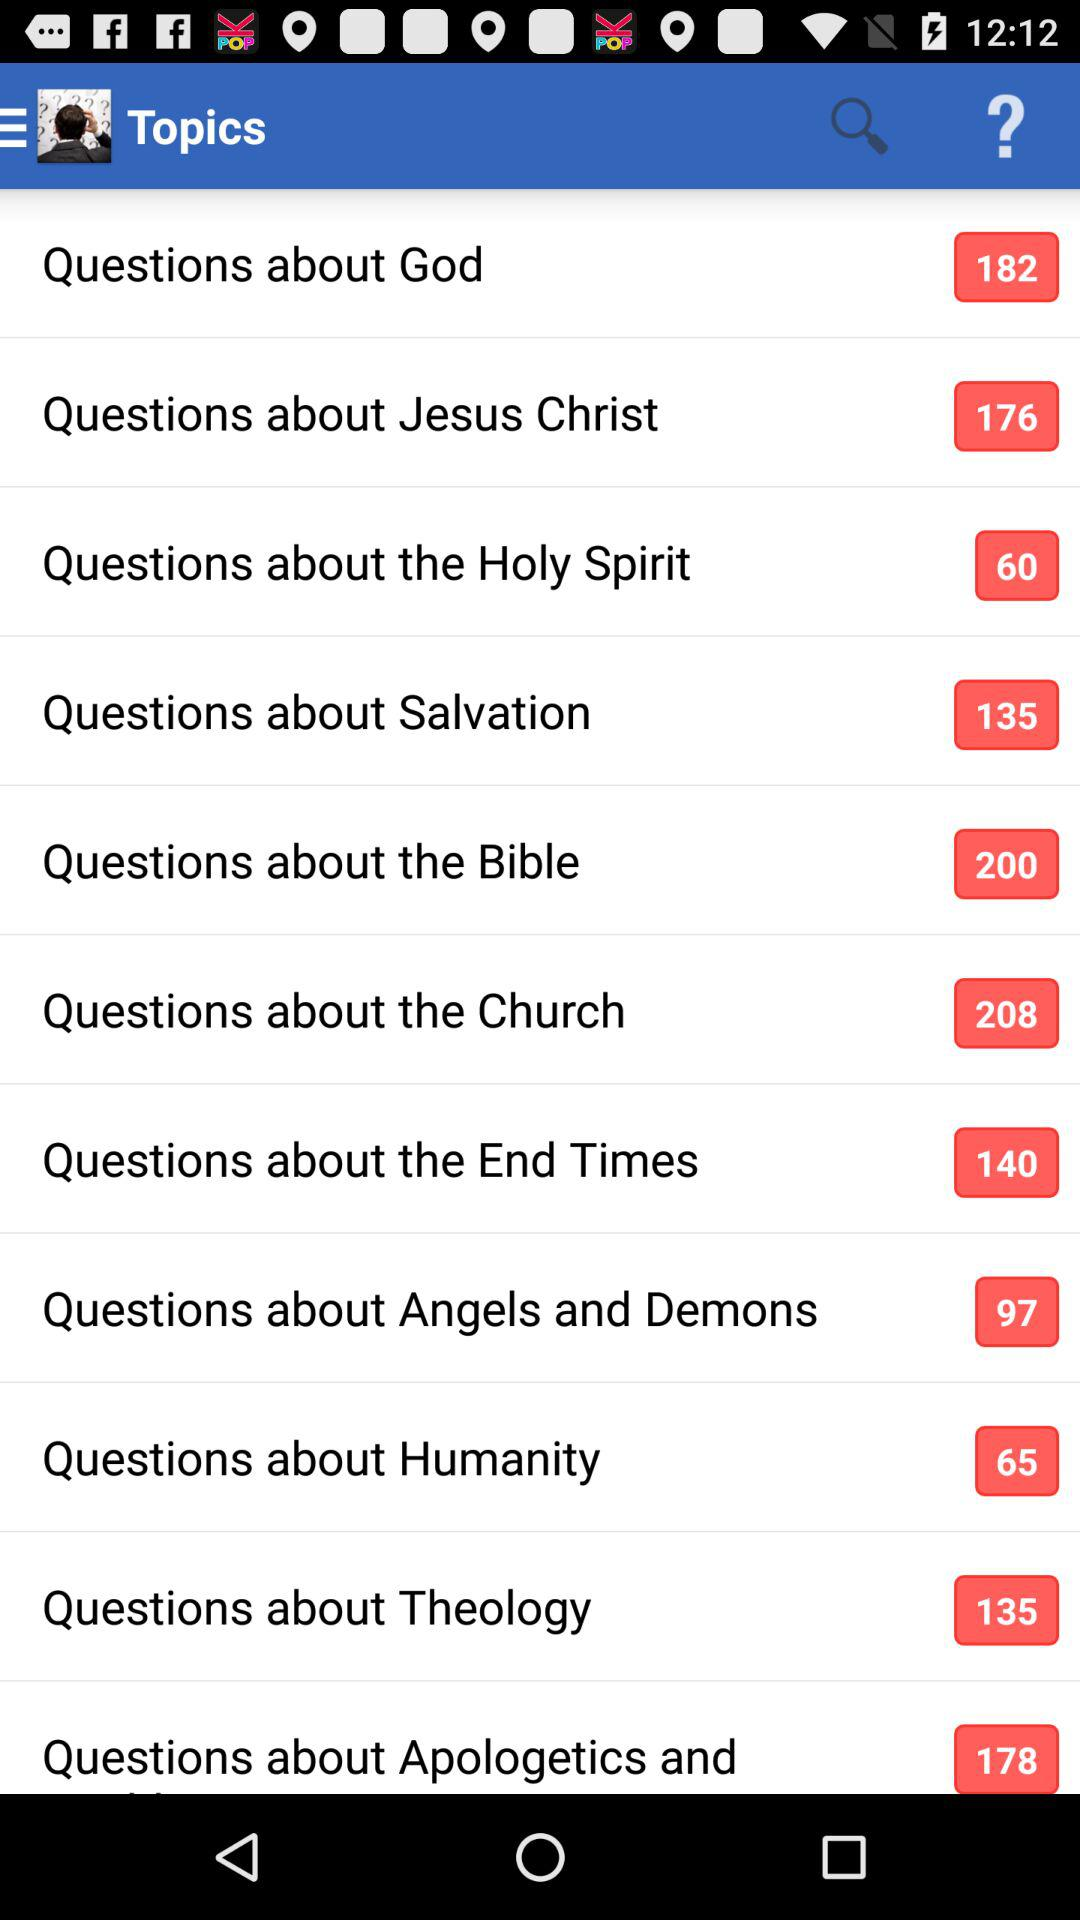How many questions are there about the church? There are 208 questions about the church. 